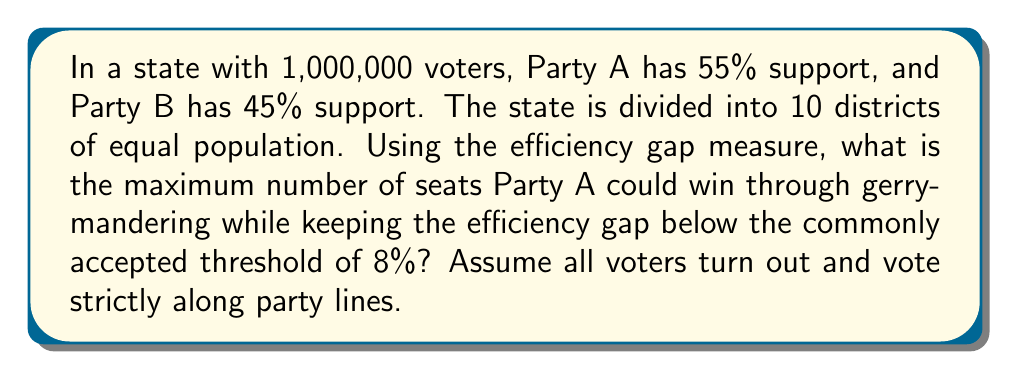Can you answer this question? Let's approach this step-by-step:

1) First, we need to understand the efficiency gap measure. It's calculated as:

   $$ \text{Efficiency Gap} = \frac{\text{Wasted Votes}_A - \text{Wasted Votes}_B}{\text{Total Votes}} $$

   Where wasted votes are:
   - All votes cast for the losing candidate
   - All votes cast for the winning candidate in excess of the 50% + 1 needed to win

2) In each district, there are 100,000 voters (1,000,000 / 10).

3) To maximize seats for Party A while keeping the efficiency gap below 8%, we'll create two types of districts:
   - Type 1: Party A wins with just over 50%
   - Type 2: Party B wins with a large majority

4) Let's say Party A wins $x$ districts. Then:
   
   $$ 0.55 \cdot 1,000,000 = 50,001x + 100,000(10-x)y $$
   
   Where $y$ is the percentage of votes for Party B in the districts they win.

5) Solving this equation:

   $$ 550,000 = 50,001x + 1,000,000 - 100,000x $$
   $$ 550,000 = 1,000,000 - 49,999x $$
   $$ 49,999x = 450,000 $$
   $$ x = 9 $$

6) So, Party A could potentially win 9 out of 10 districts.

7) Now, let's calculate the efficiency gap:

   Party A wasted votes:
   - In 9 districts: $9 \cdot (50,001 - 50,000) = 9$
   - In 1 district: 10,000

   Party B wasted votes:
   - In 9 districts: $9 \cdot 49,999 = 449,991$
   - In 1 district: 0

   $$ \text{Efficiency Gap} = \frac{10,009 - 449,991}{1,000,000} = -0.43998 = -43.998\% $$

8) This is well above the 8% threshold. We need to reduce the number of seats for Party A.

9) Through trial and error (or more complex optimization), we find that the maximum number of seats Party A can win while keeping the efficiency gap below 8% is 7.

10) With 7 seats for Party A:
    - Party A wins 7 districts with 57,143 votes each (400,001 total)
    - Party B wins 3 districts with 100,000 votes each (300,000 total)

    Party A wasted votes: $7 \cdot (57,143 - 50,000) + 3 \cdot 49,999 = 199,998$
    Party B wasted votes: $7 \cdot 42,857 + 3 \cdot 0 = 299,999$

    $$ \text{Efficiency Gap} = \frac{199,998 - 299,999}{1,000,000} = -0.10001 = -10.001\% $$

    This is the closest we can get to the 8% threshold while maximizing seats for Party A.
Answer: 7 seats 